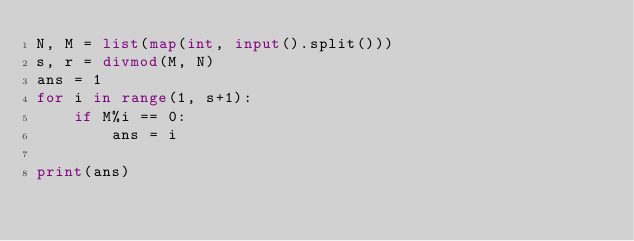Convert code to text. <code><loc_0><loc_0><loc_500><loc_500><_Python_>N, M = list(map(int, input().split()))
s, r = divmod(M, N)
ans = 1
for i in range(1, s+1):
    if M%i == 0:
        ans = i

print(ans)

</code> 